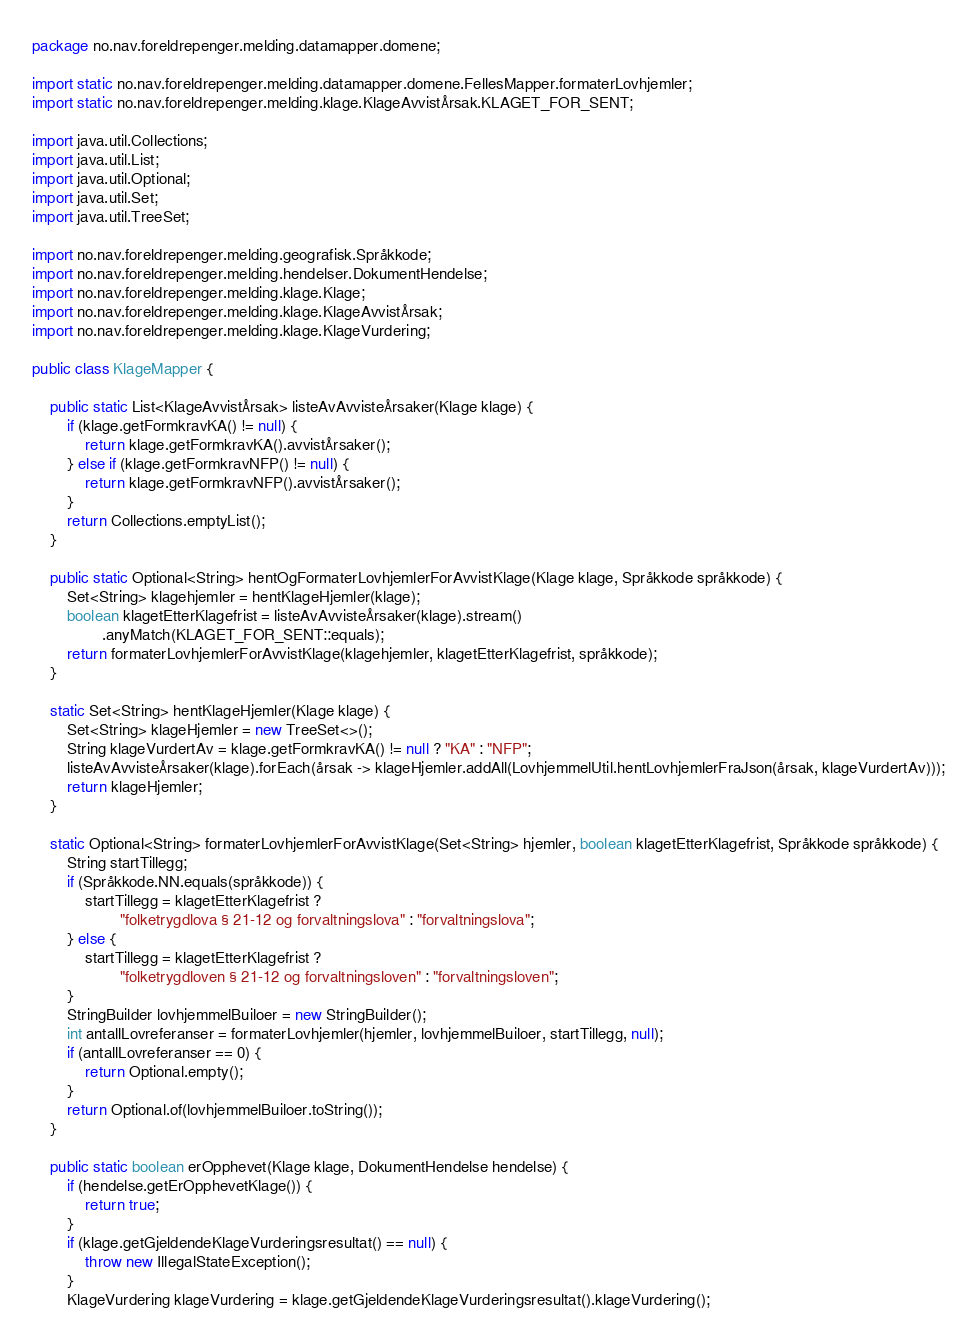Convert code to text. <code><loc_0><loc_0><loc_500><loc_500><_Java_>package no.nav.foreldrepenger.melding.datamapper.domene;

import static no.nav.foreldrepenger.melding.datamapper.domene.FellesMapper.formaterLovhjemler;
import static no.nav.foreldrepenger.melding.klage.KlageAvvistÅrsak.KLAGET_FOR_SENT;

import java.util.Collections;
import java.util.List;
import java.util.Optional;
import java.util.Set;
import java.util.TreeSet;

import no.nav.foreldrepenger.melding.geografisk.Språkkode;
import no.nav.foreldrepenger.melding.hendelser.DokumentHendelse;
import no.nav.foreldrepenger.melding.klage.Klage;
import no.nav.foreldrepenger.melding.klage.KlageAvvistÅrsak;
import no.nav.foreldrepenger.melding.klage.KlageVurdering;

public class KlageMapper {

    public static List<KlageAvvistÅrsak> listeAvAvvisteÅrsaker(Klage klage) {
        if (klage.getFormkravKA() != null) {
            return klage.getFormkravKA().avvistÅrsaker();
        } else if (klage.getFormkravNFP() != null) {
            return klage.getFormkravNFP().avvistÅrsaker();
        }
        return Collections.emptyList();
    }

    public static Optional<String> hentOgFormaterLovhjemlerForAvvistKlage(Klage klage, Språkkode språkkode) {
        Set<String> klagehjemler = hentKlageHjemler(klage);
        boolean klagetEtterKlagefrist = listeAvAvvisteÅrsaker(klage).stream()
                .anyMatch(KLAGET_FOR_SENT::equals);
        return formaterLovhjemlerForAvvistKlage(klagehjemler, klagetEtterKlagefrist, språkkode);
    }

    static Set<String> hentKlageHjemler(Klage klage) {
        Set<String> klageHjemler = new TreeSet<>();
        String klageVurdertAv = klage.getFormkravKA() != null ? "KA" : "NFP";
        listeAvAvvisteÅrsaker(klage).forEach(årsak -> klageHjemler.addAll(LovhjemmelUtil.hentLovhjemlerFraJson(årsak, klageVurdertAv)));
        return klageHjemler;
    }

    static Optional<String> formaterLovhjemlerForAvvistKlage(Set<String> hjemler, boolean klagetEtterKlagefrist, Språkkode språkkode) {
        String startTillegg;
        if (Språkkode.NN.equals(språkkode)) {
            startTillegg = klagetEtterKlagefrist ?
                    "folketrygdlova § 21-12 og forvaltningslova" : "forvaltningslova";
        } else {
            startTillegg = klagetEtterKlagefrist ?
                    "folketrygdloven § 21-12 og forvaltningsloven" : "forvaltningsloven";
        }
        StringBuilder lovhjemmelBuiloer = new StringBuilder();
        int antallLovreferanser = formaterLovhjemler(hjemler, lovhjemmelBuiloer, startTillegg, null);
        if (antallLovreferanser == 0) {
            return Optional.empty();
        }
        return Optional.of(lovhjemmelBuiloer.toString());
    }

    public static boolean erOpphevet(Klage klage, DokumentHendelse hendelse) {
        if (hendelse.getErOpphevetKlage()) {
            return true;
        }
        if (klage.getGjeldendeKlageVurderingsresultat() == null) {
            throw new IllegalStateException();
        }
        KlageVurdering klageVurdering = klage.getGjeldendeKlageVurderingsresultat().klageVurdering();</code> 